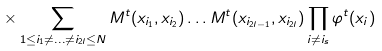<formula> <loc_0><loc_0><loc_500><loc_500>\times \sum _ { 1 \leq i _ { 1 } \ne \dots \ne i _ { 2 l } \leq N } M ^ { t } ( x _ { i _ { 1 } } , x _ { i _ { 2 } } ) \dots M ^ { t } ( x _ { i _ { 2 l - 1 } } , x _ { i _ { 2 l } } ) \prod _ { i \ne i _ { s } } \varphi ^ { t } ( x _ { i } )</formula> 